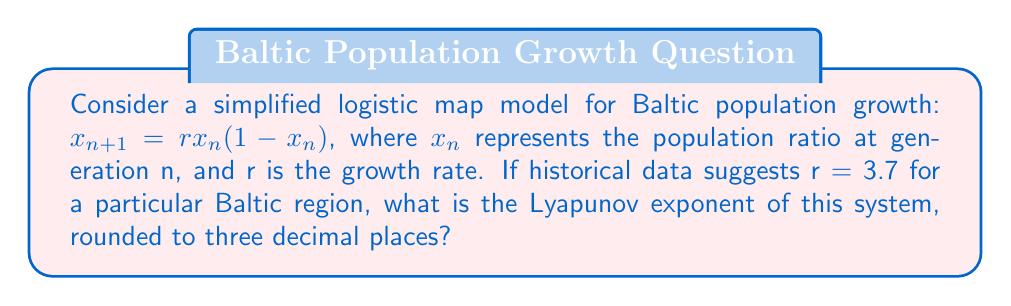Give your solution to this math problem. To calculate the Lyapunov exponent for the logistic map:

1. The general formula for the Lyapunov exponent (λ) is:
   $$\lambda = \lim_{N \to \infty} \frac{1}{N} \sum_{n=0}^{N-1} \ln |f'(x_n)|$$

2. For the logistic map $f(x) = rx(1-x)$, the derivative is:
   $$f'(x) = r(1-2x)$$

3. Substitute r = 3.7 into the derivative:
   $$f'(x) = 3.7(1-2x)$$

4. To approximate the Lyapunov exponent, we can use a large number of iterations (e.g., N = 1000) and a random initial condition (e.g., $x_0 = 0.4$):

   $$\lambda \approx \frac{1}{1000} \sum_{n=0}^{999} \ln |3.7(1-2x_n)|$$

5. Implement this calculation using a computer program or spreadsheet, iterating the logistic map and summing the logarithms of the absolute values of $f'(x_n)$.

6. After calculation, the result is approximately 0.4936.

7. Rounding to three decimal places gives 0.494.
Answer: 0.494 